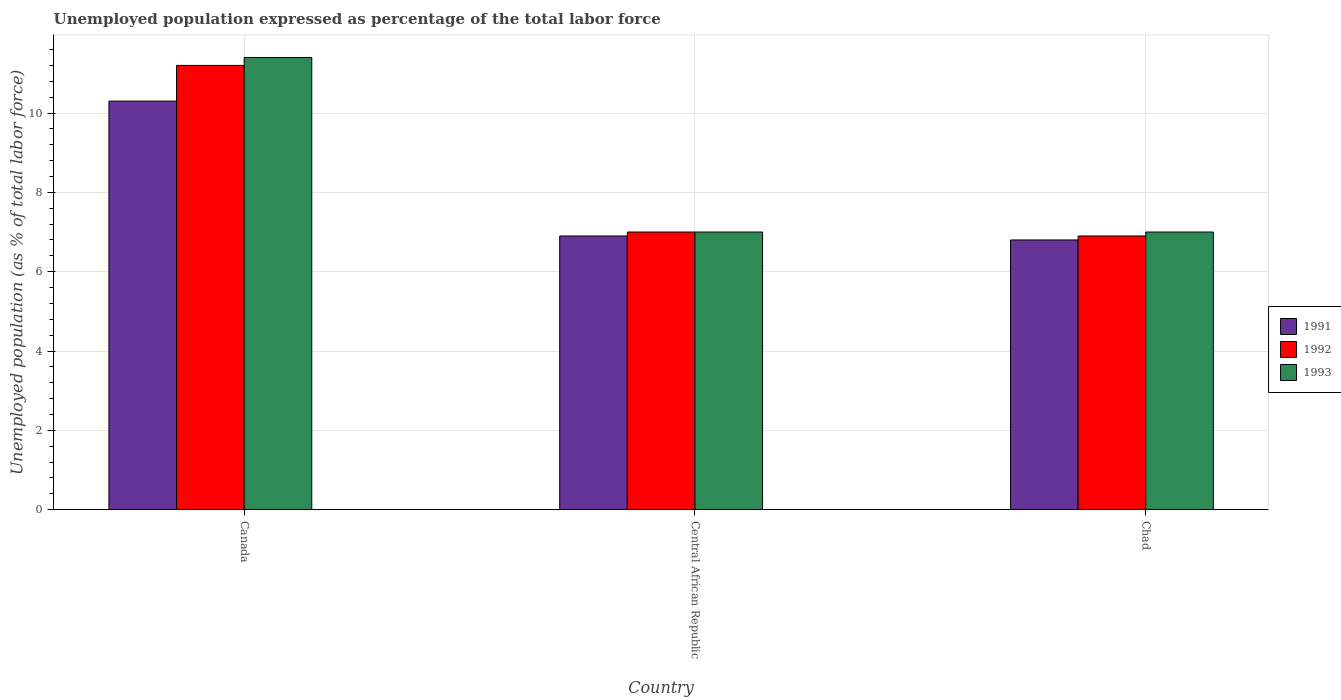How many groups of bars are there?
Give a very brief answer. 3. Are the number of bars on each tick of the X-axis equal?
Offer a terse response. Yes. How many bars are there on the 3rd tick from the left?
Your answer should be compact. 3. In how many cases, is the number of bars for a given country not equal to the number of legend labels?
Provide a succinct answer. 0. What is the unemployment in in 1991 in Central African Republic?
Your response must be concise. 6.9. Across all countries, what is the maximum unemployment in in 1992?
Make the answer very short. 11.2. Across all countries, what is the minimum unemployment in in 1993?
Keep it short and to the point. 7. In which country was the unemployment in in 1993 minimum?
Offer a terse response. Central African Republic. What is the total unemployment in in 1992 in the graph?
Provide a succinct answer. 25.1. What is the difference between the unemployment in in 1991 in Central African Republic and that in Chad?
Provide a succinct answer. 0.1. What is the average unemployment in in 1992 per country?
Give a very brief answer. 8.37. What is the difference between the unemployment in of/in 1991 and unemployment in of/in 1993 in Canada?
Provide a short and direct response. -1.1. What is the ratio of the unemployment in in 1991 in Central African Republic to that in Chad?
Offer a very short reply. 1.01. Is the difference between the unemployment in in 1991 in Canada and Central African Republic greater than the difference between the unemployment in in 1993 in Canada and Central African Republic?
Your answer should be very brief. No. What is the difference between the highest and the second highest unemployment in in 1993?
Provide a succinct answer. 4.4. What is the difference between the highest and the lowest unemployment in in 1992?
Your response must be concise. 4.3. Is the sum of the unemployment in in 1993 in Canada and Chad greater than the maximum unemployment in in 1992 across all countries?
Provide a succinct answer. Yes. What does the 1st bar from the left in Chad represents?
Give a very brief answer. 1991. What does the 2nd bar from the right in Canada represents?
Provide a short and direct response. 1992. Is it the case that in every country, the sum of the unemployment in in 1993 and unemployment in in 1992 is greater than the unemployment in in 1991?
Your answer should be very brief. Yes. Are all the bars in the graph horizontal?
Your response must be concise. No. How many countries are there in the graph?
Keep it short and to the point. 3. Are the values on the major ticks of Y-axis written in scientific E-notation?
Keep it short and to the point. No. Where does the legend appear in the graph?
Keep it short and to the point. Center right. How many legend labels are there?
Give a very brief answer. 3. What is the title of the graph?
Your answer should be compact. Unemployed population expressed as percentage of the total labor force. What is the label or title of the X-axis?
Your response must be concise. Country. What is the label or title of the Y-axis?
Your answer should be compact. Unemployed population (as % of total labor force). What is the Unemployed population (as % of total labor force) of 1991 in Canada?
Your response must be concise. 10.3. What is the Unemployed population (as % of total labor force) in 1992 in Canada?
Your response must be concise. 11.2. What is the Unemployed population (as % of total labor force) in 1993 in Canada?
Provide a succinct answer. 11.4. What is the Unemployed population (as % of total labor force) in 1991 in Central African Republic?
Your answer should be compact. 6.9. What is the Unemployed population (as % of total labor force) in 1992 in Central African Republic?
Make the answer very short. 7. What is the Unemployed population (as % of total labor force) of 1991 in Chad?
Keep it short and to the point. 6.8. What is the Unemployed population (as % of total labor force) in 1992 in Chad?
Your response must be concise. 6.9. What is the Unemployed population (as % of total labor force) of 1993 in Chad?
Your answer should be compact. 7. Across all countries, what is the maximum Unemployed population (as % of total labor force) of 1991?
Make the answer very short. 10.3. Across all countries, what is the maximum Unemployed population (as % of total labor force) of 1992?
Offer a terse response. 11.2. Across all countries, what is the maximum Unemployed population (as % of total labor force) of 1993?
Provide a short and direct response. 11.4. Across all countries, what is the minimum Unemployed population (as % of total labor force) in 1991?
Your answer should be very brief. 6.8. Across all countries, what is the minimum Unemployed population (as % of total labor force) in 1992?
Offer a terse response. 6.9. What is the total Unemployed population (as % of total labor force) in 1991 in the graph?
Offer a terse response. 24. What is the total Unemployed population (as % of total labor force) of 1992 in the graph?
Provide a short and direct response. 25.1. What is the total Unemployed population (as % of total labor force) of 1993 in the graph?
Offer a terse response. 25.4. What is the difference between the Unemployed population (as % of total labor force) in 1991 in Canada and that in Central African Republic?
Your response must be concise. 3.4. What is the difference between the Unemployed population (as % of total labor force) of 1992 in Canada and that in Central African Republic?
Provide a succinct answer. 4.2. What is the difference between the Unemployed population (as % of total labor force) of 1991 in Canada and that in Chad?
Your response must be concise. 3.5. What is the difference between the Unemployed population (as % of total labor force) in 1992 in Canada and that in Chad?
Your response must be concise. 4.3. What is the difference between the Unemployed population (as % of total labor force) in 1993 in Canada and that in Chad?
Provide a short and direct response. 4.4. What is the difference between the Unemployed population (as % of total labor force) of 1992 in Central African Republic and that in Chad?
Give a very brief answer. 0.1. What is the difference between the Unemployed population (as % of total labor force) of 1991 in Canada and the Unemployed population (as % of total labor force) of 1992 in Central African Republic?
Make the answer very short. 3.3. What is the difference between the Unemployed population (as % of total labor force) of 1991 in Canada and the Unemployed population (as % of total labor force) of 1992 in Chad?
Your answer should be compact. 3.4. What is the difference between the Unemployed population (as % of total labor force) in 1992 in Canada and the Unemployed population (as % of total labor force) in 1993 in Chad?
Make the answer very short. 4.2. What is the difference between the Unemployed population (as % of total labor force) of 1991 in Central African Republic and the Unemployed population (as % of total labor force) of 1992 in Chad?
Your response must be concise. 0. What is the difference between the Unemployed population (as % of total labor force) of 1991 in Central African Republic and the Unemployed population (as % of total labor force) of 1993 in Chad?
Offer a terse response. -0.1. What is the average Unemployed population (as % of total labor force) of 1991 per country?
Your response must be concise. 8. What is the average Unemployed population (as % of total labor force) of 1992 per country?
Your response must be concise. 8.37. What is the average Unemployed population (as % of total labor force) in 1993 per country?
Give a very brief answer. 8.47. What is the difference between the Unemployed population (as % of total labor force) in 1991 and Unemployed population (as % of total labor force) in 1993 in Canada?
Provide a succinct answer. -1.1. What is the difference between the Unemployed population (as % of total labor force) of 1992 and Unemployed population (as % of total labor force) of 1993 in Canada?
Offer a terse response. -0.2. What is the difference between the Unemployed population (as % of total labor force) of 1991 and Unemployed population (as % of total labor force) of 1992 in Central African Republic?
Provide a succinct answer. -0.1. What is the difference between the Unemployed population (as % of total labor force) in 1991 and Unemployed population (as % of total labor force) in 1993 in Central African Republic?
Offer a terse response. -0.1. What is the difference between the Unemployed population (as % of total labor force) in 1992 and Unemployed population (as % of total labor force) in 1993 in Central African Republic?
Offer a very short reply. 0. What is the difference between the Unemployed population (as % of total labor force) in 1991 and Unemployed population (as % of total labor force) in 1993 in Chad?
Make the answer very short. -0.2. What is the difference between the Unemployed population (as % of total labor force) in 1992 and Unemployed population (as % of total labor force) in 1993 in Chad?
Give a very brief answer. -0.1. What is the ratio of the Unemployed population (as % of total labor force) in 1991 in Canada to that in Central African Republic?
Make the answer very short. 1.49. What is the ratio of the Unemployed population (as % of total labor force) in 1992 in Canada to that in Central African Republic?
Make the answer very short. 1.6. What is the ratio of the Unemployed population (as % of total labor force) of 1993 in Canada to that in Central African Republic?
Make the answer very short. 1.63. What is the ratio of the Unemployed population (as % of total labor force) of 1991 in Canada to that in Chad?
Offer a very short reply. 1.51. What is the ratio of the Unemployed population (as % of total labor force) in 1992 in Canada to that in Chad?
Your answer should be compact. 1.62. What is the ratio of the Unemployed population (as % of total labor force) of 1993 in Canada to that in Chad?
Provide a short and direct response. 1.63. What is the ratio of the Unemployed population (as % of total labor force) in 1991 in Central African Republic to that in Chad?
Offer a terse response. 1.01. What is the ratio of the Unemployed population (as % of total labor force) in 1992 in Central African Republic to that in Chad?
Your answer should be very brief. 1.01. What is the ratio of the Unemployed population (as % of total labor force) in 1993 in Central African Republic to that in Chad?
Ensure brevity in your answer.  1. What is the difference between the highest and the second highest Unemployed population (as % of total labor force) in 1991?
Give a very brief answer. 3.4. What is the difference between the highest and the second highest Unemployed population (as % of total labor force) in 1993?
Your answer should be very brief. 4.4. What is the difference between the highest and the lowest Unemployed population (as % of total labor force) of 1991?
Give a very brief answer. 3.5. 